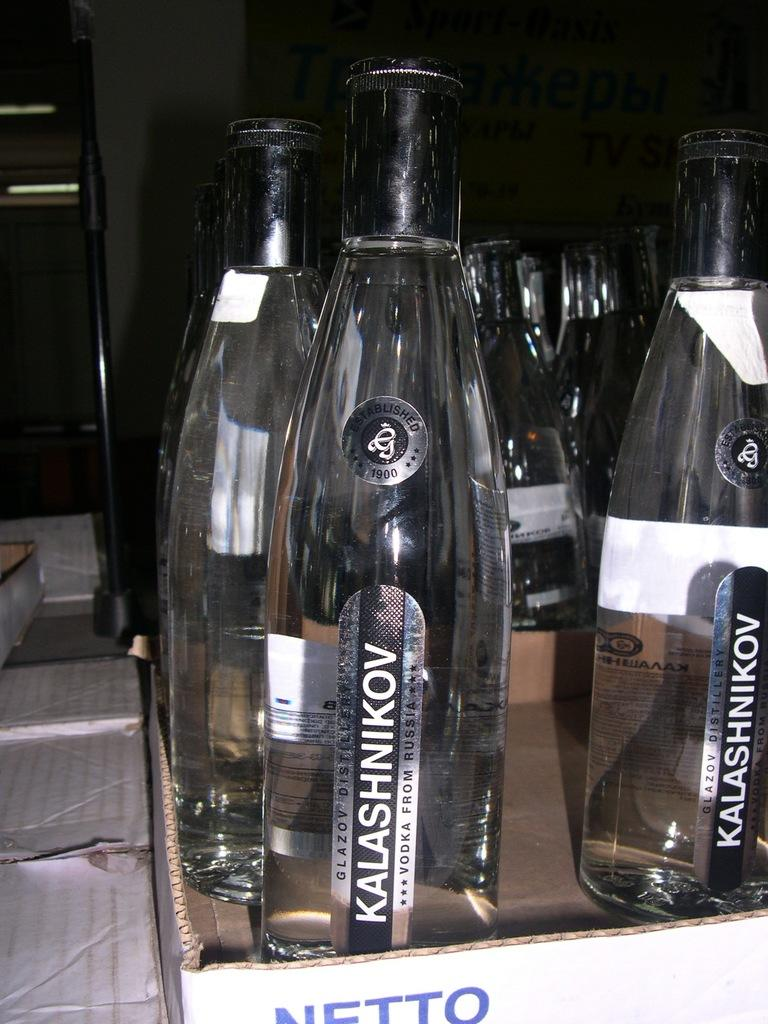<image>
Present a compact description of the photo's key features. Empty bottles of KALASHNIKOV Russian vodka sitting in a cardboard NETTO box on a table. 